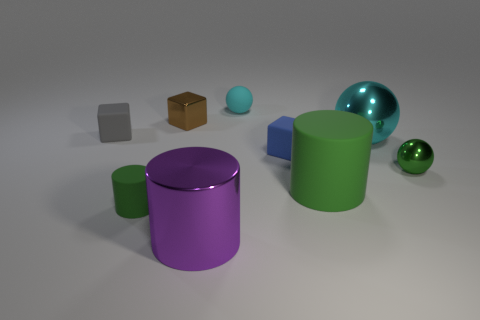Subtract all tiny gray rubber blocks. How many blocks are left? 2 Subtract all purple cylinders. How many cylinders are left? 2 Subtract all cubes. How many objects are left? 6 Subtract 2 cylinders. How many cylinders are left? 1 Subtract all cyan cylinders. Subtract all red cubes. How many cylinders are left? 3 Add 7 small green things. How many small green things are left? 9 Add 5 brown blocks. How many brown blocks exist? 6 Subtract 0 yellow balls. How many objects are left? 9 Subtract all red blocks. How many brown spheres are left? 0 Subtract all tiny gray shiny objects. Subtract all tiny brown metal things. How many objects are left? 8 